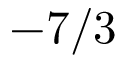<formula> <loc_0><loc_0><loc_500><loc_500>- 7 / 3</formula> 